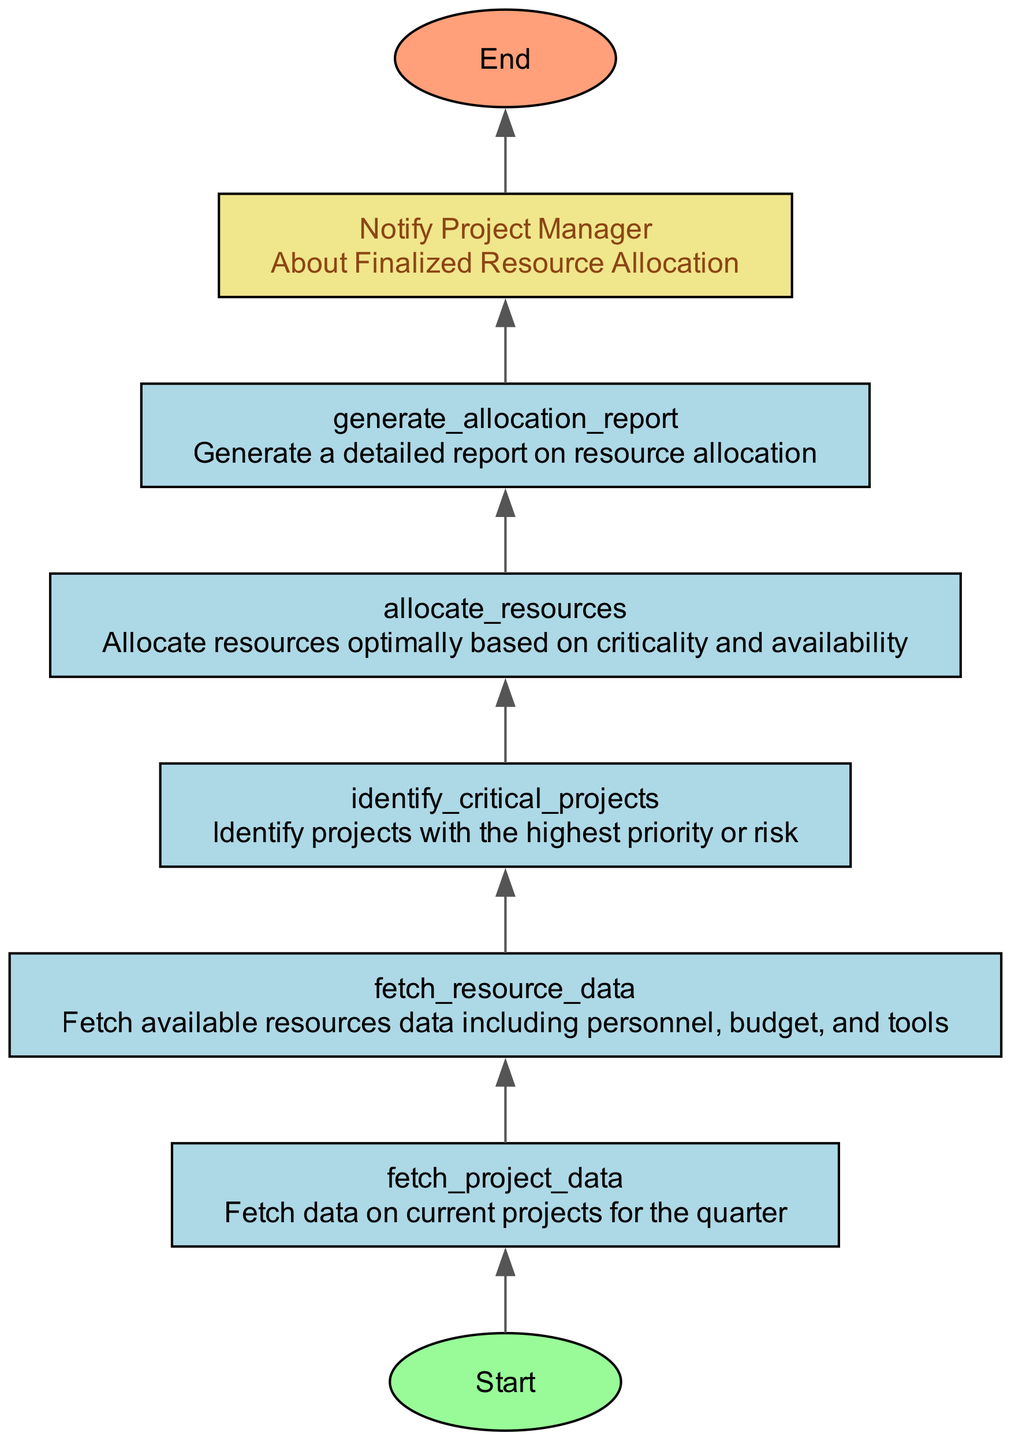What is the first step in the flowchart? The first step in the flowchart is indicated by the "start" node, which represents the beginning of the function.
Answer: Start How many nodes are there in the flowchart? By counting each unique element specified in the diagram's data, we find there are eight nodes, including the start and end nodes.
Answer: Eight What is the last action before completing the function? The last action before completing the function is "notify_project_manager," which indicates communication regarding the finalized resource allocation.
Answer: Notify Project Manager Which node deals with resource data? The node responsible for resource data is "fetch_resource_data," which is where available resources such as personnel, budget, and tools are retrieved.
Answer: Fetch Resource Data What are the three main categories of resource data mentioned? The three main categories mentioned are personnel, budget, and tools, which are included in the available resources data fetched in the flowchart.
Answer: Personnel, Budget, Tools What step follows "identify_critical_projects"? The step that follows "identify_critical_projects" is "allocate_resources," indicating that once critical projects are identified, resources will be allocated based on that identification.
Answer: Allocate Resources Which node generates a report after resource allocation? The node that generates a report after resource allocation is "generate_allocation_report," where a detailed report is created regarding how resources are allocated.
Answer: Generate Allocation Report How does the flowchart begin and end? The flowchart begins with the "start" node and ends with the "end" node, indicating the complete cycle of the function from initiation to conclusion.
Answer: Start and End 